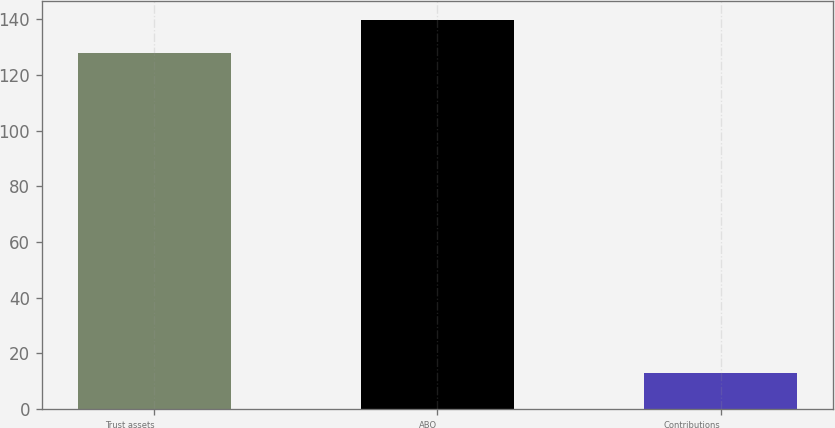<chart> <loc_0><loc_0><loc_500><loc_500><bar_chart><fcel>Trust assets<fcel>ABO<fcel>Contributions<nl><fcel>128<fcel>139.7<fcel>13<nl></chart> 